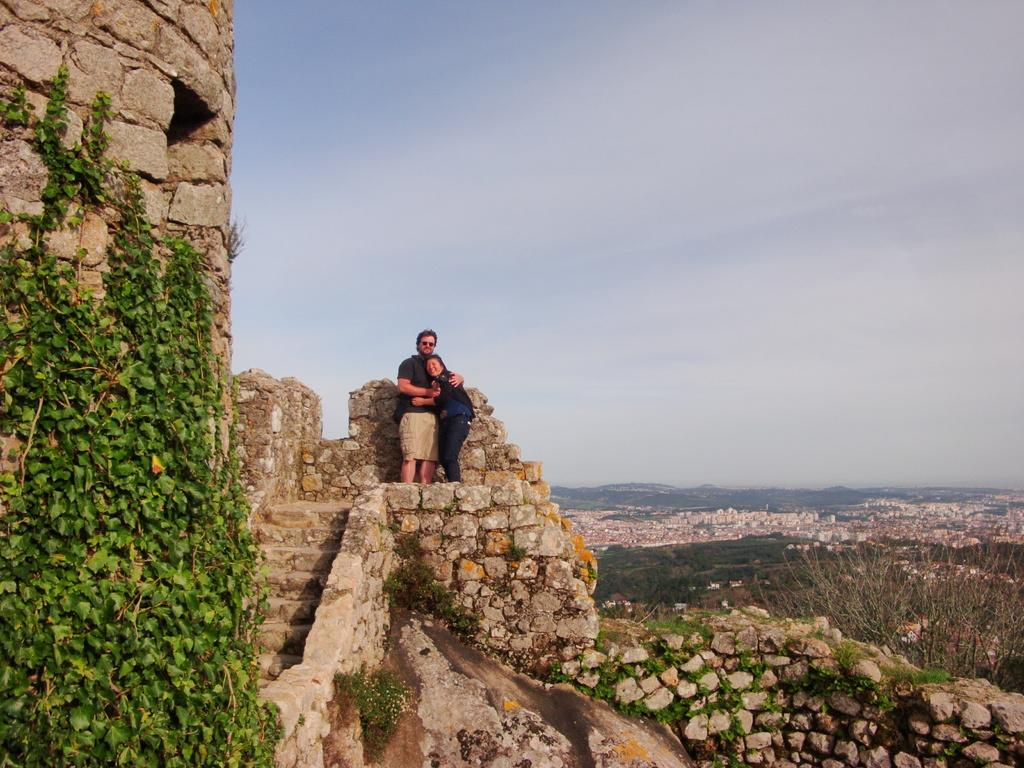How many people are in the image? There are two people in the image. Where are the people standing in the image? The people are standing on a fort. What else can be seen in the image besides the people? There is a plant in the image. What is the condition of the sky in the image? The sky is clear in the image. What subject is the person on the left teaching in the image? There is no indication in the image that the person on the left is teaching a subject. 